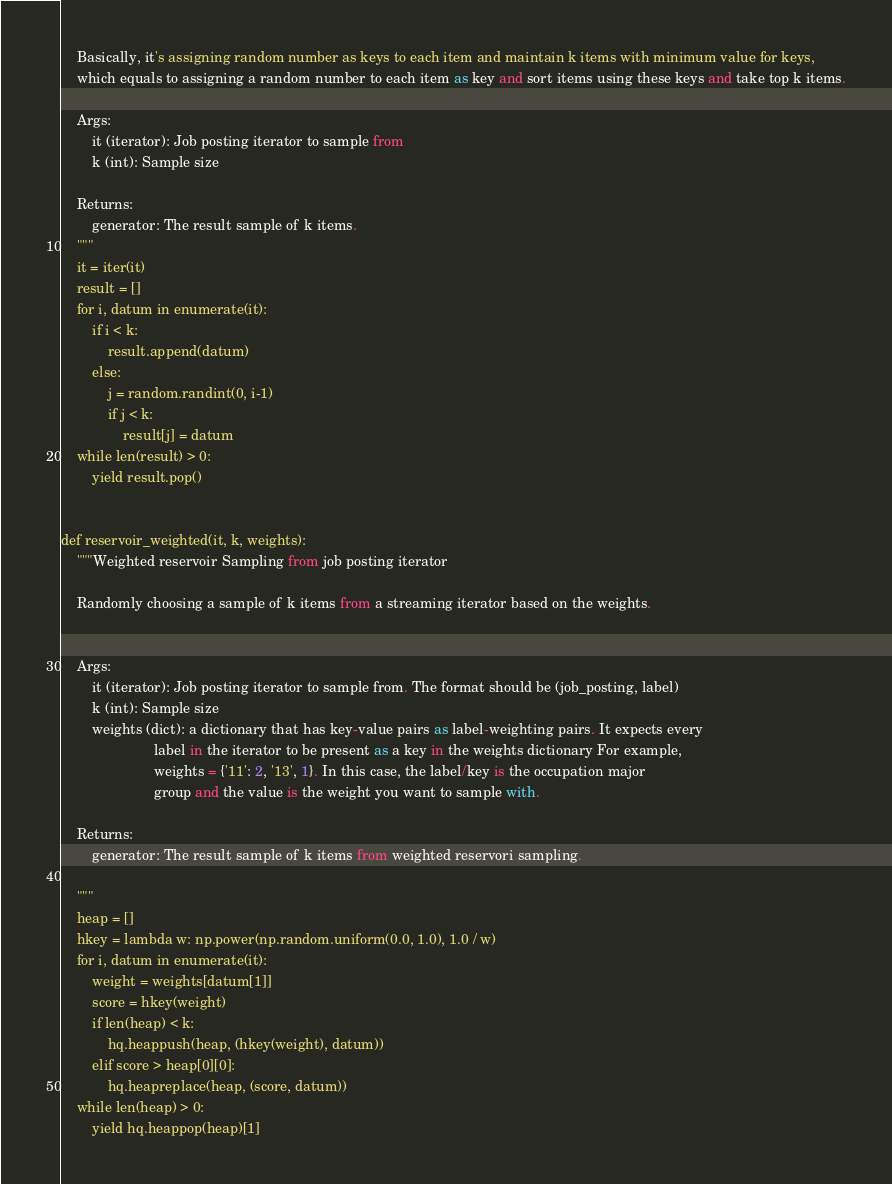<code> <loc_0><loc_0><loc_500><loc_500><_Python_>    Basically, it's assigning random number as keys to each item and maintain k items with minimum value for keys,
    which equals to assigning a random number to each item as key and sort items using these keys and take top k items.

    Args:
        it (iterator): Job posting iterator to sample from
        k (int): Sample size

    Returns:
        generator: The result sample of k items.
    """
    it = iter(it)
    result = []
    for i, datum in enumerate(it):
        if i < k:
            result.append(datum)
        else:
            j = random.randint(0, i-1)
            if j < k:
                result[j] = datum
    while len(result) > 0:
        yield result.pop()


def reservoir_weighted(it, k, weights):
    """Weighted reservoir Sampling from job posting iterator

    Randomly choosing a sample of k items from a streaming iterator based on the weights.


    Args:
        it (iterator): Job posting iterator to sample from. The format should be (job_posting, label)
        k (int): Sample size
        weights (dict): a dictionary that has key-value pairs as label-weighting pairs. It expects every
                        label in the iterator to be present as a key in the weights dictionary For example,
                        weights = {'11': 2, '13', 1}. In this case, the label/key is the occupation major
                        group and the value is the weight you want to sample with.

    Returns:
        generator: The result sample of k items from weighted reservori sampling.

    """
    heap = []
    hkey = lambda w: np.power(np.random.uniform(0.0, 1.0), 1.0 / w)
    for i, datum in enumerate(it):
        weight = weights[datum[1]]
        score = hkey(weight)
        if len(heap) < k:
            hq.heappush(heap, (hkey(weight), datum))
        elif score > heap[0][0]:
            hq.heapreplace(heap, (score, datum))
    while len(heap) > 0:
        yield hq.heappop(heap)[1]
</code> 